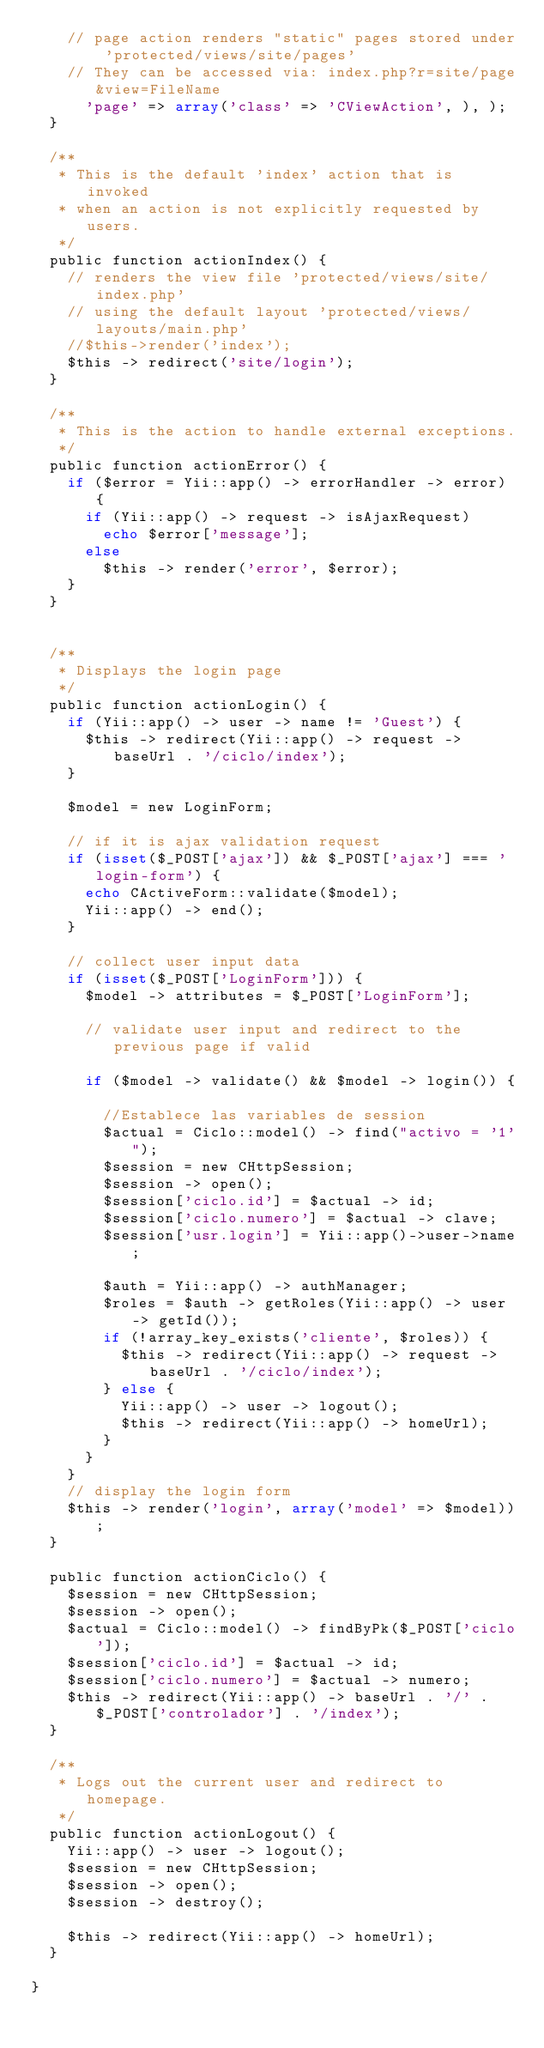<code> <loc_0><loc_0><loc_500><loc_500><_PHP_>		// page action renders "static" pages stored under 'protected/views/site/pages'
		// They can be accessed via: index.php?r=site/page&view=FileName
			'page' => array('class' => 'CViewAction', ), );
	}

	/**
	 * This is the default 'index' action that is invoked
	 * when an action is not explicitly requested by users.
	 */
	public function actionIndex() {
		// renders the view file 'protected/views/site/index.php'
		// using the default layout 'protected/views/layouts/main.php'
		//$this->render('index');
		$this -> redirect('site/login');
	}

	/**
	 * This is the action to handle external exceptions.
	 */
	public function actionError() {
		if ($error = Yii::app() -> errorHandler -> error) {
			if (Yii::app() -> request -> isAjaxRequest)
				echo $error['message'];
			else
				$this -> render('error', $error);
		}
	}


	/**
	 * Displays the login page
	 */
	public function actionLogin() {
		if (Yii::app() -> user -> name != 'Guest') {
			$this -> redirect(Yii::app() -> request -> baseUrl . '/ciclo/index');
		}

		$model = new LoginForm;

		// if it is ajax validation request
		if (isset($_POST['ajax']) && $_POST['ajax'] === 'login-form') {
			echo CActiveForm::validate($model);
			Yii::app() -> end();
		}

		// collect user input data
		if (isset($_POST['LoginForm'])) {
			$model -> attributes = $_POST['LoginForm'];

			// validate user input and redirect to the previous page if valid

			if ($model -> validate() && $model -> login()) {

				//Establece las variables de session
				$actual = Ciclo::model() -> find("activo = '1'");
				$session = new CHttpSession;
				$session -> open();
				$session['ciclo.id'] = $actual -> id;
				$session['ciclo.numero'] = $actual -> clave;
				$session['usr.login'] = Yii::app()->user->name;

				$auth = Yii::app() -> authManager;
				$roles = $auth -> getRoles(Yii::app() -> user -> getId());
				if (!array_key_exists('cliente', $roles)) {
					$this -> redirect(Yii::app() -> request -> baseUrl . '/ciclo/index');
				} else {
					Yii::app() -> user -> logout();
					$this -> redirect(Yii::app() -> homeUrl);
				}
			}
		}
		// display the login form
		$this -> render('login', array('model' => $model));
	}

	public function actionCiclo() {
		$session = new CHttpSession;
		$session -> open();
		$actual = Ciclo::model() -> findByPk($_POST['ciclo']);
		$session['ciclo.id'] = $actual -> id;
		$session['ciclo.numero'] = $actual -> numero;
		$this -> redirect(Yii::app() -> baseUrl . '/' . $_POST['controlador'] . '/index');
	}

	/**
	 * Logs out the current user and redirect to homepage.
	 */
	public function actionLogout() {
		Yii::app() -> user -> logout();
		$session = new CHttpSession;
		$session -> open();
		$session -> destroy();

		$this -> redirect(Yii::app() -> homeUrl);
	}

}
</code> 